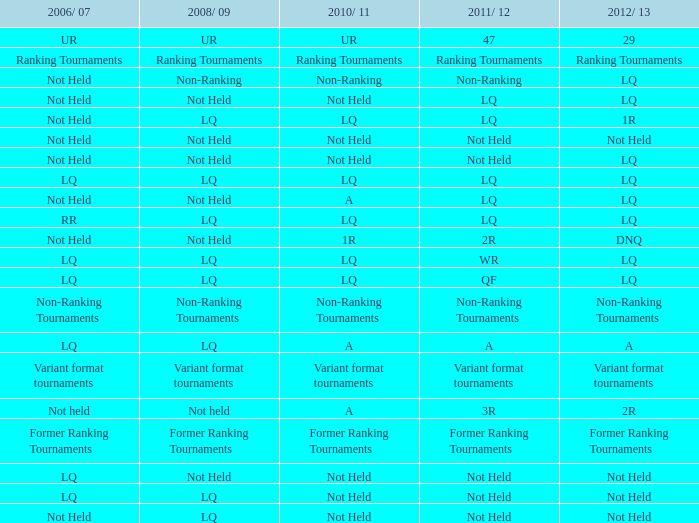What is 2006/07, when 2011/12 is referred to as lq, and when 2010/11 is called lq? Not Held, LQ, RR. 